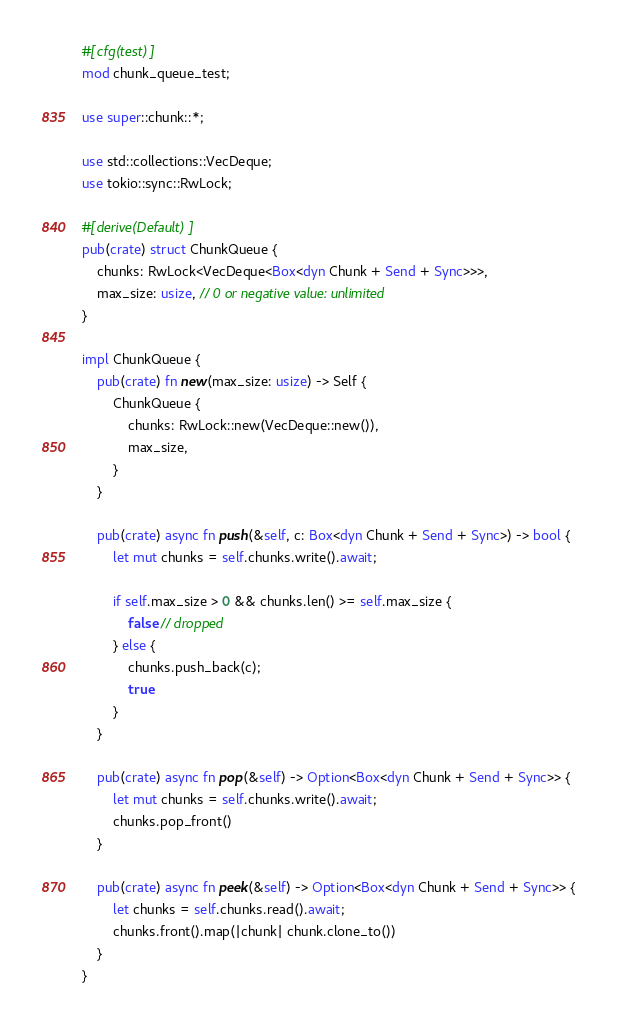<code> <loc_0><loc_0><loc_500><loc_500><_Rust_>#[cfg(test)]
mod chunk_queue_test;

use super::chunk::*;

use std::collections::VecDeque;
use tokio::sync::RwLock;

#[derive(Default)]
pub(crate) struct ChunkQueue {
    chunks: RwLock<VecDeque<Box<dyn Chunk + Send + Sync>>>,
    max_size: usize, // 0 or negative value: unlimited
}

impl ChunkQueue {
    pub(crate) fn new(max_size: usize) -> Self {
        ChunkQueue {
            chunks: RwLock::new(VecDeque::new()),
            max_size,
        }
    }

    pub(crate) async fn push(&self, c: Box<dyn Chunk + Send + Sync>) -> bool {
        let mut chunks = self.chunks.write().await;

        if self.max_size > 0 && chunks.len() >= self.max_size {
            false // dropped
        } else {
            chunks.push_back(c);
            true
        }
    }

    pub(crate) async fn pop(&self) -> Option<Box<dyn Chunk + Send + Sync>> {
        let mut chunks = self.chunks.write().await;
        chunks.pop_front()
    }

    pub(crate) async fn peek(&self) -> Option<Box<dyn Chunk + Send + Sync>> {
        let chunks = self.chunks.read().await;
        chunks.front().map(|chunk| chunk.clone_to())
    }
}
</code> 